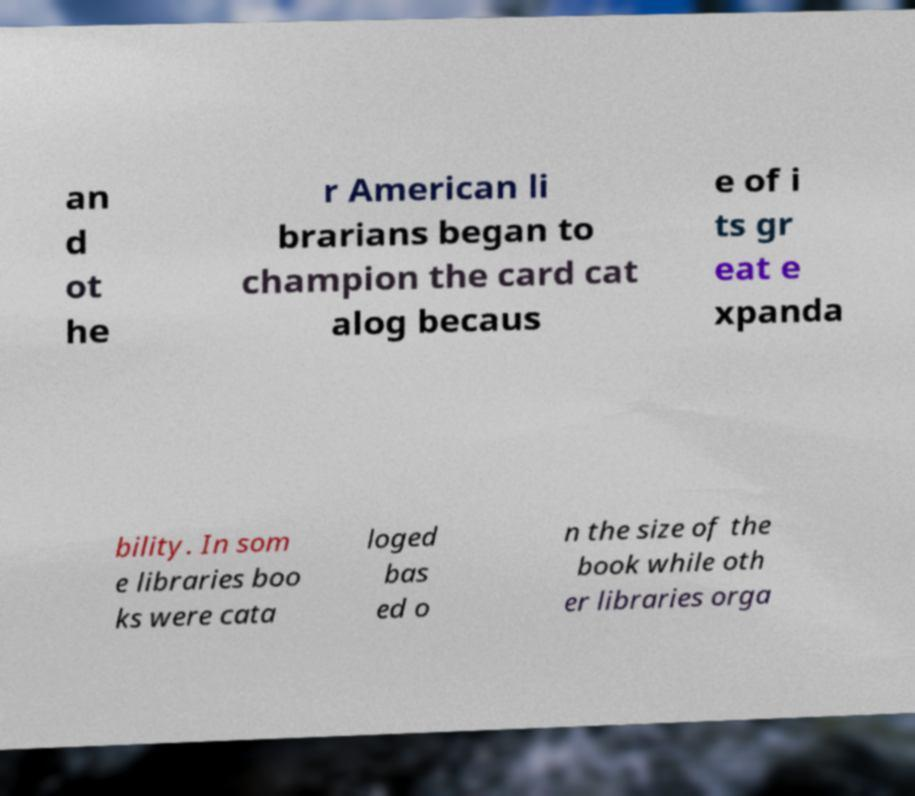Please read and relay the text visible in this image. What does it say? an d ot he r American li brarians began to champion the card cat alog becaus e of i ts gr eat e xpanda bility. In som e libraries boo ks were cata loged bas ed o n the size of the book while oth er libraries orga 